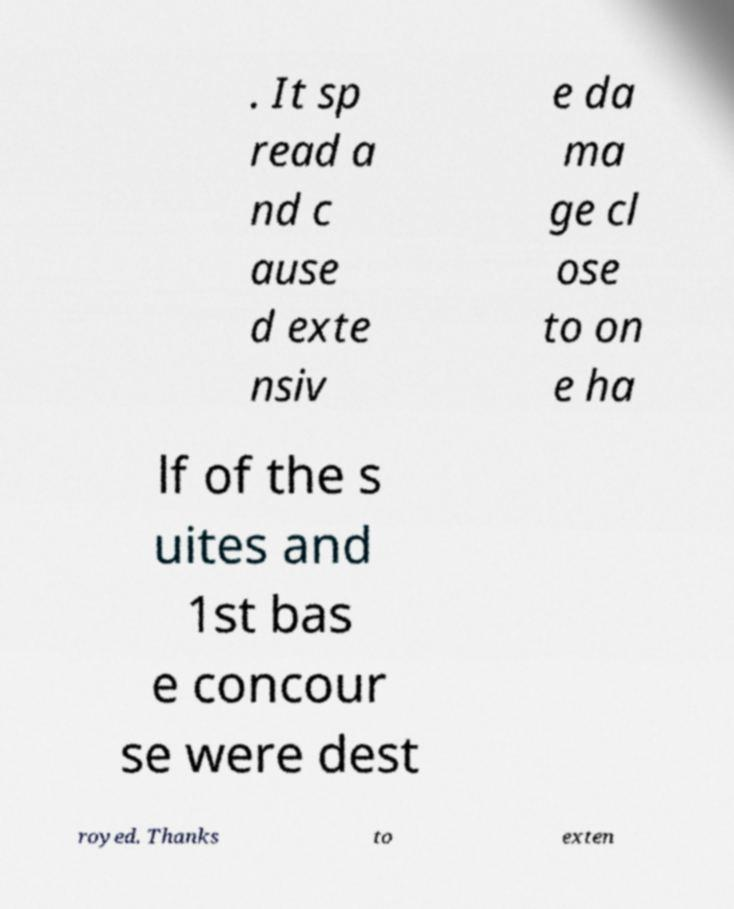Can you accurately transcribe the text from the provided image for me? . It sp read a nd c ause d exte nsiv e da ma ge cl ose to on e ha lf of the s uites and 1st bas e concour se were dest royed. Thanks to exten 